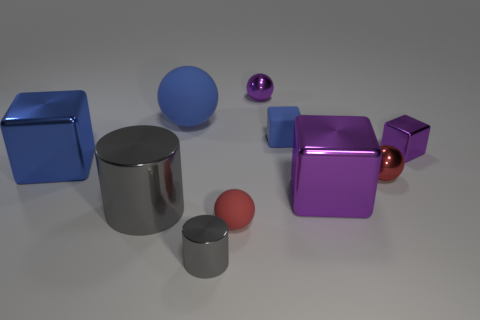Subtract all spheres. How many objects are left? 6 Add 8 gray matte cylinders. How many gray matte cylinders exist? 8 Subtract 0 cyan blocks. How many objects are left? 10 Subtract all red metallic objects. Subtract all small purple balls. How many objects are left? 8 Add 5 red matte spheres. How many red matte spheres are left? 6 